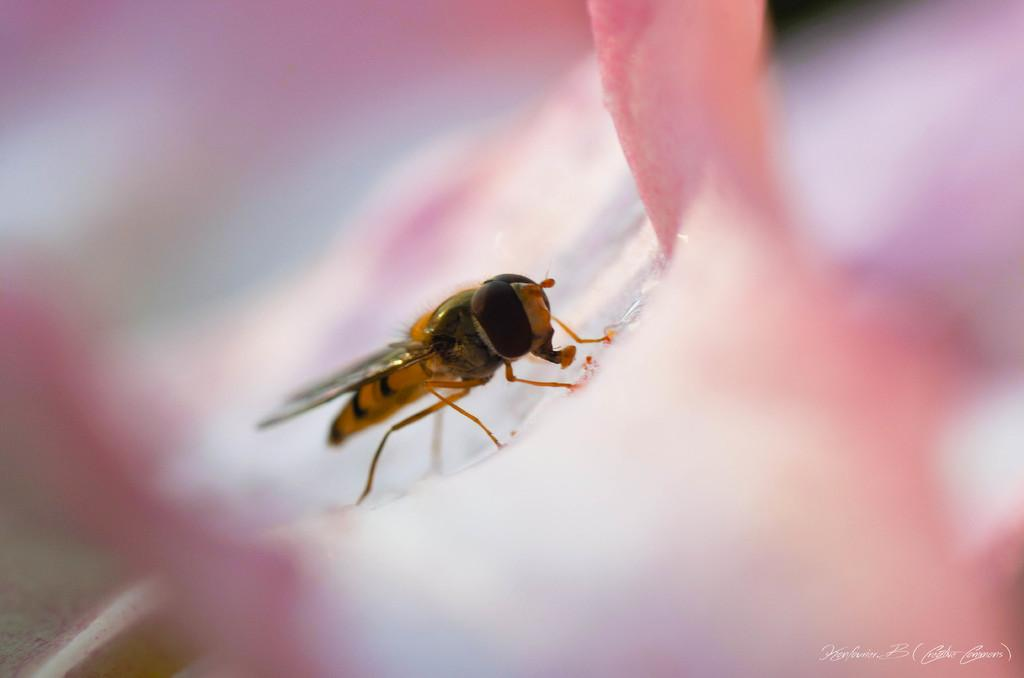What type of creature can be seen in the image? There is an insect in the image. Where is the insect located in the image? The insect is on a surface. What type of pets are visible in the image? There are no pets visible in the image; it only features an insect on a surface. What type of gardening tool can be seen in the image? There is no gardening tool, such as a spade, present in the image. 